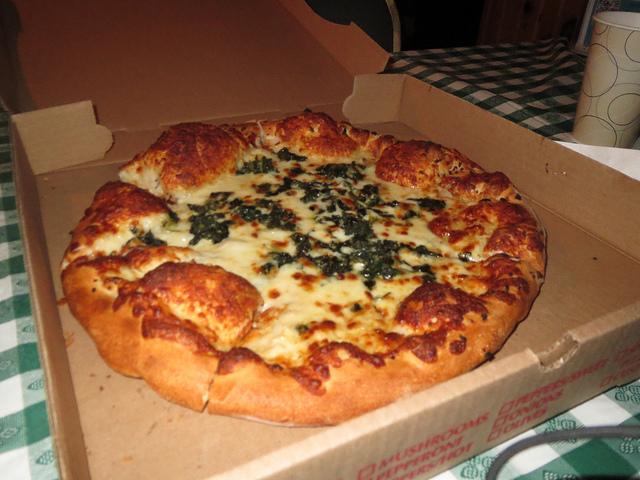What are the toppings?
Short answer required. Spinach and cheese. What kind of pizza is in this photo?
Give a very brief answer. Spinach. How many cups are on the table?
Concise answer only. 1. What is the pizza in?
Write a very short answer. Pizza box. What is the type of pizza?
Be succinct. Cheese. 